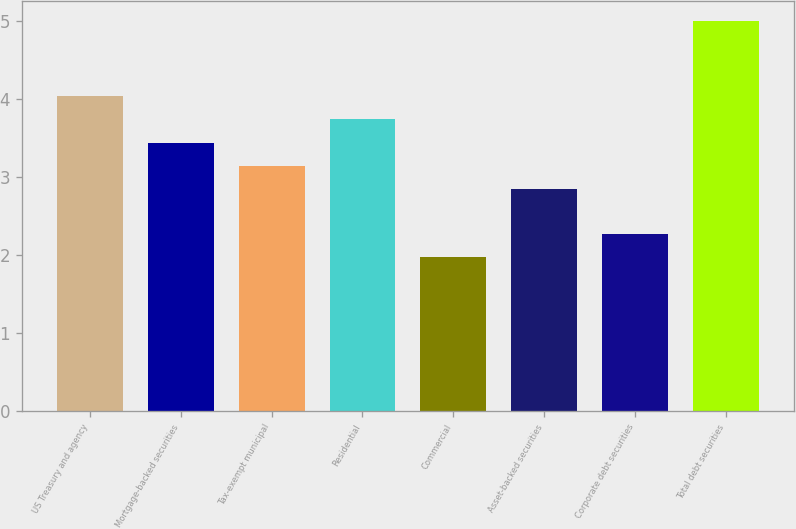Convert chart. <chart><loc_0><loc_0><loc_500><loc_500><bar_chart><fcel>US Treasury and agency<fcel>Mortgage-backed securities<fcel>Tax-exempt municipal<fcel>Residential<fcel>Commercial<fcel>Asset-backed securities<fcel>Corporate debt securities<fcel>Total debt securities<nl><fcel>4.04<fcel>3.44<fcel>3.14<fcel>3.74<fcel>1.97<fcel>2.84<fcel>2.27<fcel>5<nl></chart> 